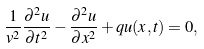<formula> <loc_0><loc_0><loc_500><loc_500>\frac { 1 } { v ^ { 2 } } \frac { \partial ^ { 2 } u } { \partial t ^ { 2 } } - \frac { \partial ^ { 2 } u } { \partial x ^ { 2 } } + q u ( x , t ) = 0 ,</formula> 